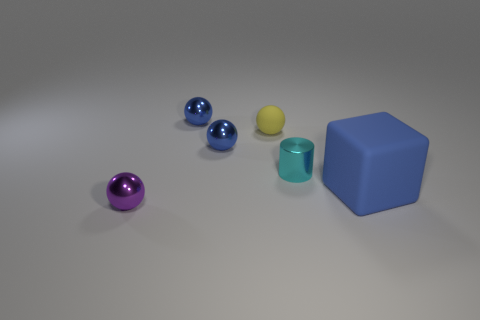There is a blue object that is right of the tiny cyan shiny cylinder; what is its shape?
Your response must be concise. Cube. Do the big thing and the cylinder have the same material?
Keep it short and to the point. No. Is there any other thing that is made of the same material as the small yellow thing?
Offer a terse response. Yes. There is a tiny yellow object that is the same shape as the tiny purple thing; what is its material?
Your answer should be very brief. Rubber. Are there fewer blue metal spheres that are left of the small purple metal thing than tiny blocks?
Give a very brief answer. No. There is a cylinder; what number of rubber things are behind it?
Provide a short and direct response. 1. There is a tiny metal object in front of the cylinder; does it have the same shape as the tiny object that is to the right of the matte ball?
Your answer should be very brief. No. What is the shape of the blue object that is both in front of the small yellow matte object and to the left of the tiny shiny cylinder?
Provide a short and direct response. Sphere. What size is the purple object that is made of the same material as the tiny cyan cylinder?
Provide a succinct answer. Small. Are there fewer blue objects than purple metal things?
Give a very brief answer. No. 